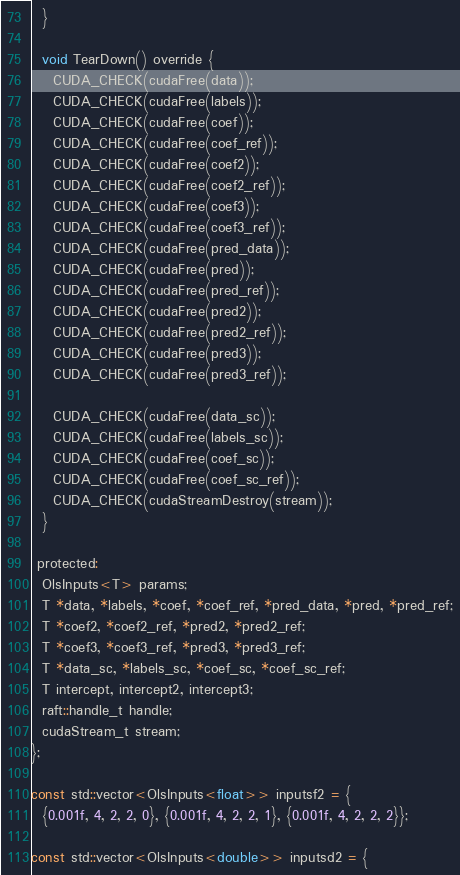<code> <loc_0><loc_0><loc_500><loc_500><_Cuda_>  }

  void TearDown() override {
    CUDA_CHECK(cudaFree(data));
    CUDA_CHECK(cudaFree(labels));
    CUDA_CHECK(cudaFree(coef));
    CUDA_CHECK(cudaFree(coef_ref));
    CUDA_CHECK(cudaFree(coef2));
    CUDA_CHECK(cudaFree(coef2_ref));
    CUDA_CHECK(cudaFree(coef3));
    CUDA_CHECK(cudaFree(coef3_ref));
    CUDA_CHECK(cudaFree(pred_data));
    CUDA_CHECK(cudaFree(pred));
    CUDA_CHECK(cudaFree(pred_ref));
    CUDA_CHECK(cudaFree(pred2));
    CUDA_CHECK(cudaFree(pred2_ref));
    CUDA_CHECK(cudaFree(pred3));
    CUDA_CHECK(cudaFree(pred3_ref));

    CUDA_CHECK(cudaFree(data_sc));
    CUDA_CHECK(cudaFree(labels_sc));
    CUDA_CHECK(cudaFree(coef_sc));
    CUDA_CHECK(cudaFree(coef_sc_ref));
    CUDA_CHECK(cudaStreamDestroy(stream));
  }

 protected:
  OlsInputs<T> params;
  T *data, *labels, *coef, *coef_ref, *pred_data, *pred, *pred_ref;
  T *coef2, *coef2_ref, *pred2, *pred2_ref;
  T *coef3, *coef3_ref, *pred3, *pred3_ref;
  T *data_sc, *labels_sc, *coef_sc, *coef_sc_ref;
  T intercept, intercept2, intercept3;
  raft::handle_t handle;
  cudaStream_t stream;
};

const std::vector<OlsInputs<float>> inputsf2 = {
  {0.001f, 4, 2, 2, 0}, {0.001f, 4, 2, 2, 1}, {0.001f, 4, 2, 2, 2}};

const std::vector<OlsInputs<double>> inputsd2 = {</code> 